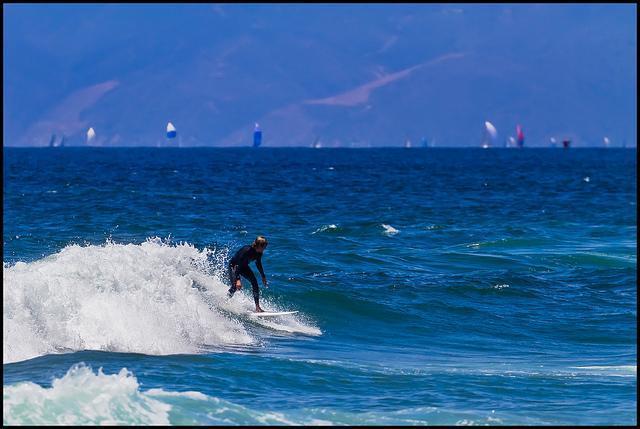How many surfer are in the water?
Give a very brief answer. 1. How many kites are white?
Give a very brief answer. 0. 